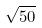Convert formula to latex. <formula><loc_0><loc_0><loc_500><loc_500>\sqrt { 5 0 }</formula> 